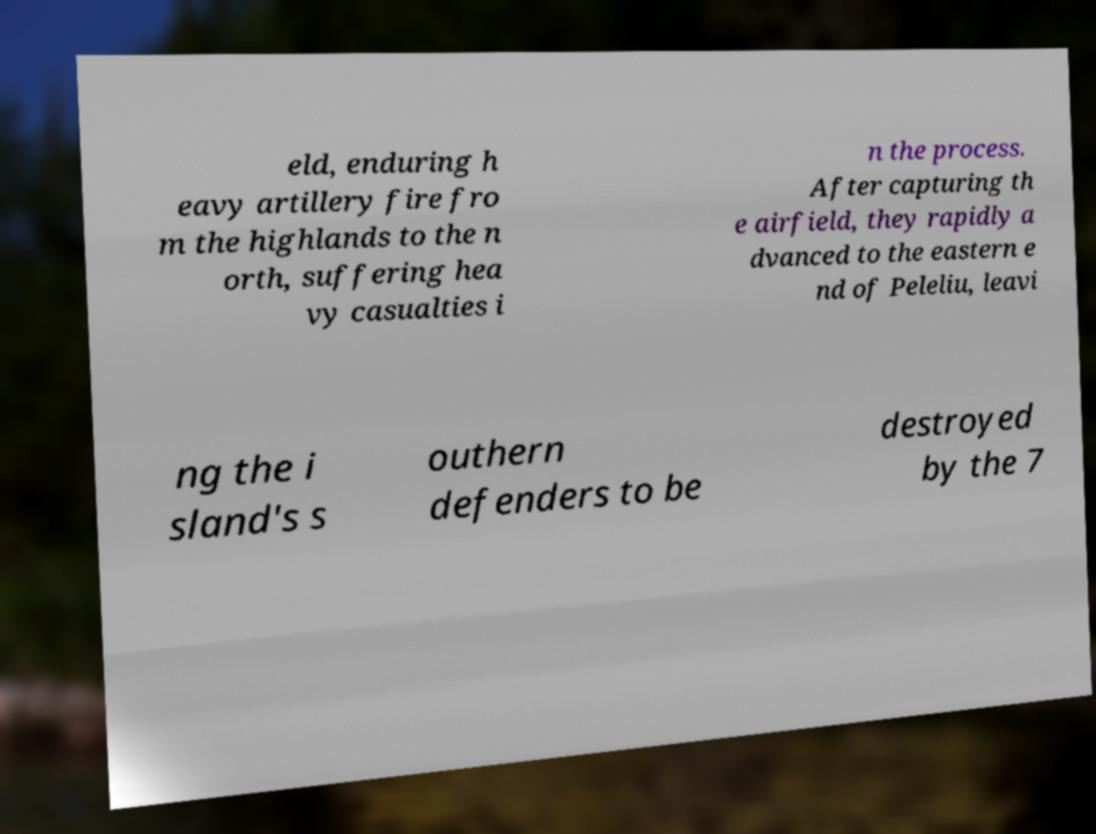Please read and relay the text visible in this image. What does it say? eld, enduring h eavy artillery fire fro m the highlands to the n orth, suffering hea vy casualties i n the process. After capturing th e airfield, they rapidly a dvanced to the eastern e nd of Peleliu, leavi ng the i sland's s outhern defenders to be destroyed by the 7 